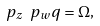<formula> <loc_0><loc_0><loc_500><loc_500>\ p _ { z } \ p _ { w } q = \Omega ,</formula> 